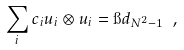Convert formula to latex. <formula><loc_0><loc_0><loc_500><loc_500>\sum _ { i } c _ { i } { u } _ { i } \otimes { u } _ { i } = \i d _ { N ^ { 2 } - 1 } \ ,</formula> 